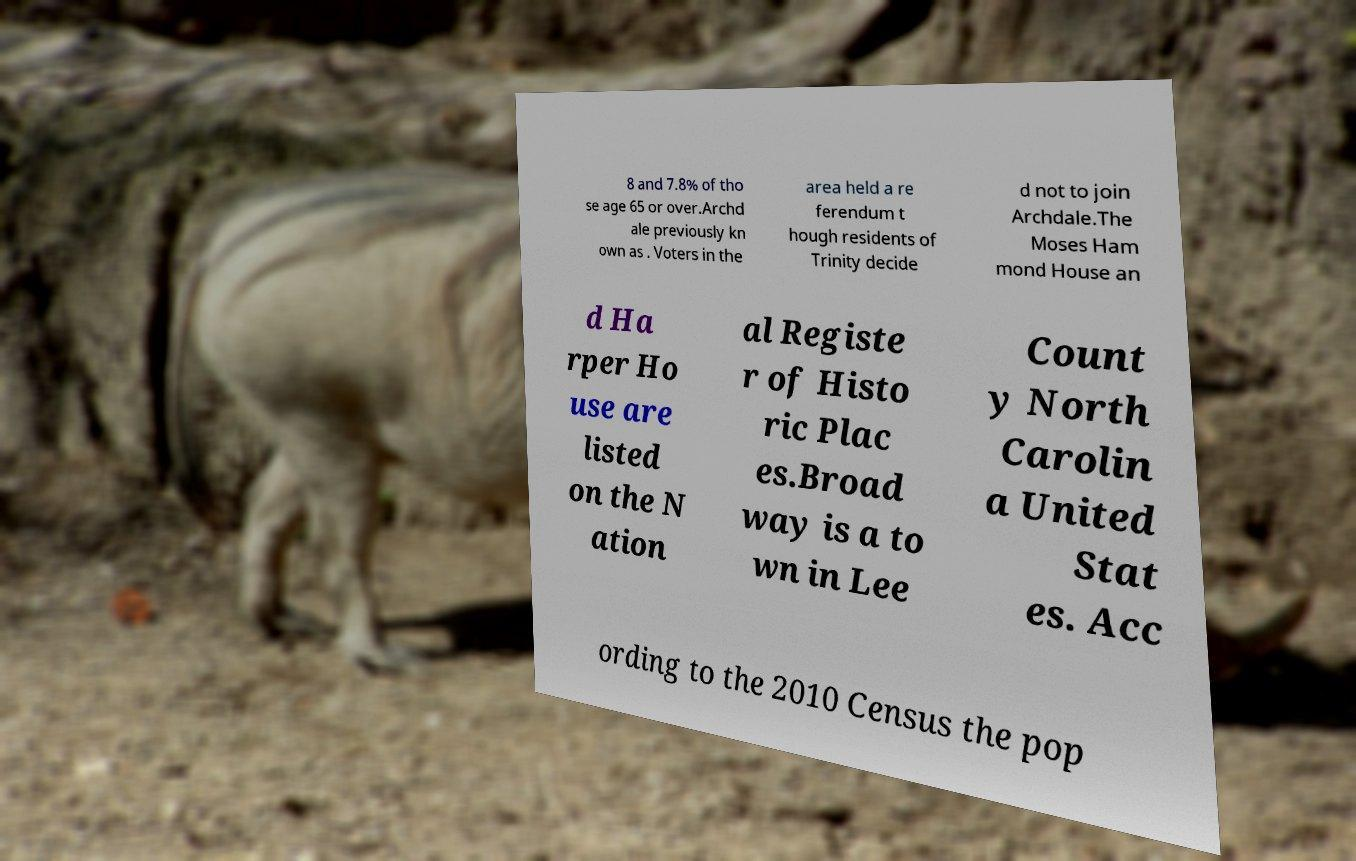What messages or text are displayed in this image? I need them in a readable, typed format. 8 and 7.8% of tho se age 65 or over.Archd ale previously kn own as . Voters in the area held a re ferendum t hough residents of Trinity decide d not to join Archdale.The Moses Ham mond House an d Ha rper Ho use are listed on the N ation al Registe r of Histo ric Plac es.Broad way is a to wn in Lee Count y North Carolin a United Stat es. Acc ording to the 2010 Census the pop 